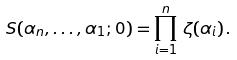<formula> <loc_0><loc_0><loc_500><loc_500>S ( \alpha _ { n } , \dots , \alpha _ { 1 } ; 0 ) = \prod _ { i = 1 } ^ { n } \, \zeta ( \alpha _ { i } ) \, .</formula> 